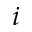Convert formula to latex. <formula><loc_0><loc_0><loc_500><loc_500>i</formula> 